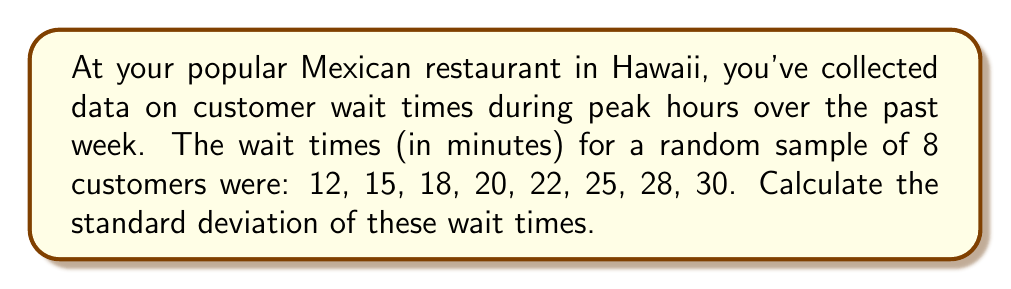Give your solution to this math problem. To calculate the standard deviation, we'll follow these steps:

1. Calculate the mean (μ) of the wait times:
   $$\mu = \frac{12 + 15 + 18 + 20 + 22 + 25 + 28 + 30}{8} = \frac{170}{8} = 21.25$$

2. Calculate the squared differences from the mean:
   $$(12 - 21.25)^2 = (-9.25)^2 = 85.5625$$
   $$(15 - 21.25)^2 = (-6.25)^2 = 39.0625$$
   $$(18 - 21.25)^2 = (-3.25)^2 = 10.5625$$
   $$(20 - 21.25)^2 = (-1.25)^2 = 1.5625$$
   $$(22 - 21.25)^2 = (0.75)^2 = 0.5625$$
   $$(25 - 21.25)^2 = (3.75)^2 = 14.0625$$
   $$(28 - 21.25)^2 = (6.75)^2 = 45.5625$$
   $$(30 - 21.25)^2 = (8.75)^2 = 76.5625$$

3. Calculate the variance (σ²) by taking the average of these squared differences:
   $$\sigma^2 = \frac{85.5625 + 39.0625 + 10.5625 + 1.5625 + 0.5625 + 14.0625 + 45.5625 + 76.5625}{8} = \frac{273.5}{8} = 34.1875$$

4. Calculate the standard deviation (σ) by taking the square root of the variance:
   $$\sigma = \sqrt{34.1875} \approx 5.85$$
Answer: $5.85$ minutes 